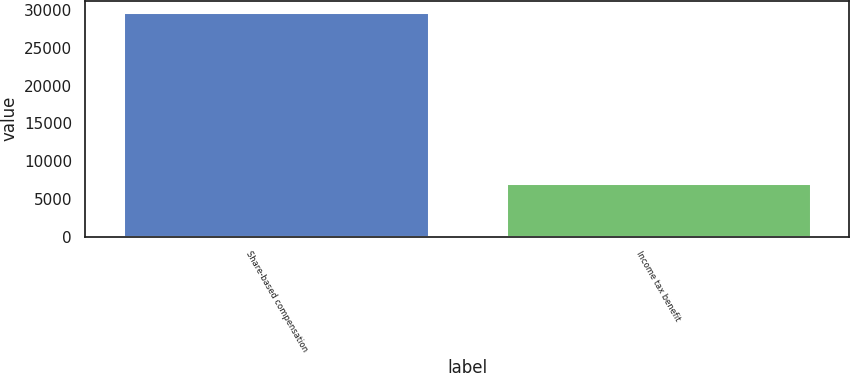Convert chart to OTSL. <chart><loc_0><loc_0><loc_500><loc_500><bar_chart><fcel>Share-based compensation<fcel>Income tax benefit<nl><fcel>29793<fcel>7126<nl></chart> 